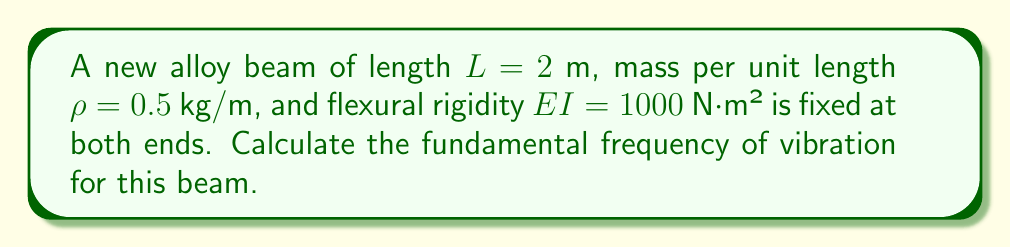Can you answer this question? To solve this problem, we'll follow these steps:

1) For a beam fixed at both ends, the frequency equation is:

   $$f_n = \frac{(\beta_n L)^2}{2\pi L^2}\sqrt{\frac{EI}{\rho}}$$

   where $n$ is the mode number and $\beta_n L$ is a constant that depends on the boundary conditions.

2) For the fundamental frequency (n = 1), $\beta_1 L = 4.730$.

3) Substitute the given values:
   $L = 2$ m
   $\rho = 0.5$ kg/m
   $EI = 1000$ N·m²

4) Calculate:

   $$f_1 = \frac{(4.730)^2}{2\pi (2)^2}\sqrt{\frac{1000}{0.5}}$$

5) Simplify:

   $$f_1 = \frac{22.3729}{4\pi}\sqrt{2000}$$

6) Evaluate:

   $$f_1 = 1.7783 \times \sqrt{2000} = 79.5 \text{ Hz}$$
Answer: $79.5 \text{ Hz}$ 